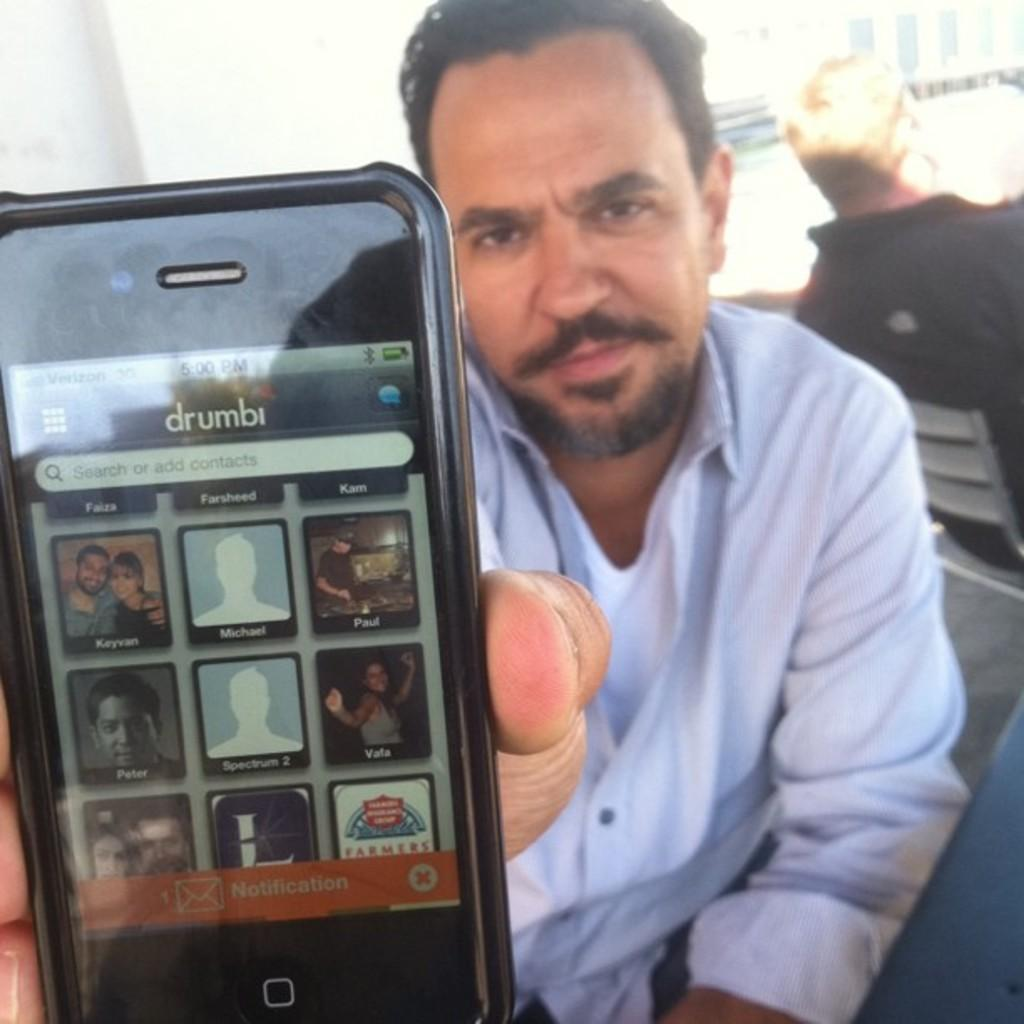What is the man in the image holding? The man is holding a mobile in the image. How is the man holding the mobile? The man is holding the mobile in his hand. What can be seen on the mobile screen? There are pictures visible on the mobile screen. Can you describe the other person in the image? There is another man sitting on a chair in the background of the image. What type of ship can be seen in the image? There is no ship present in the image. How does the end of the conversation increase the understanding of the image? The conversation does not involve any increase in understanding related to the end, as the focus is on the details of the image provided in the facts. 